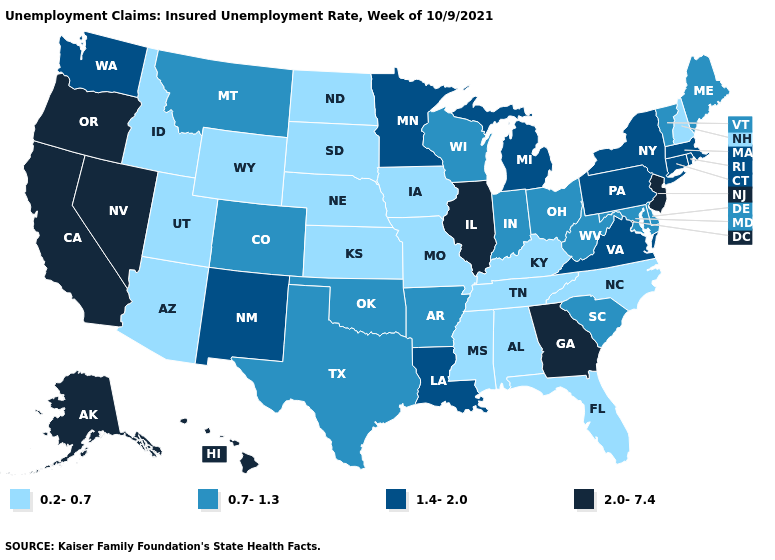What is the lowest value in states that border Idaho?
Answer briefly. 0.2-0.7. What is the lowest value in the USA?
Quick response, please. 0.2-0.7. Name the states that have a value in the range 0.2-0.7?
Keep it brief. Alabama, Arizona, Florida, Idaho, Iowa, Kansas, Kentucky, Mississippi, Missouri, Nebraska, New Hampshire, North Carolina, North Dakota, South Dakota, Tennessee, Utah, Wyoming. How many symbols are there in the legend?
Concise answer only. 4. Does Connecticut have the same value as Maine?
Write a very short answer. No. What is the highest value in states that border Georgia?
Quick response, please. 0.7-1.3. What is the value of North Dakota?
Write a very short answer. 0.2-0.7. Among the states that border Iowa , does Minnesota have the highest value?
Be succinct. No. Name the states that have a value in the range 1.4-2.0?
Quick response, please. Connecticut, Louisiana, Massachusetts, Michigan, Minnesota, New Mexico, New York, Pennsylvania, Rhode Island, Virginia, Washington. How many symbols are there in the legend?
Be succinct. 4. Is the legend a continuous bar?
Write a very short answer. No. Among the states that border South Carolina , does Georgia have the lowest value?
Give a very brief answer. No. What is the value of South Dakota?
Give a very brief answer. 0.2-0.7. Name the states that have a value in the range 1.4-2.0?
Keep it brief. Connecticut, Louisiana, Massachusetts, Michigan, Minnesota, New Mexico, New York, Pennsylvania, Rhode Island, Virginia, Washington. Name the states that have a value in the range 2.0-7.4?
Concise answer only. Alaska, California, Georgia, Hawaii, Illinois, Nevada, New Jersey, Oregon. 